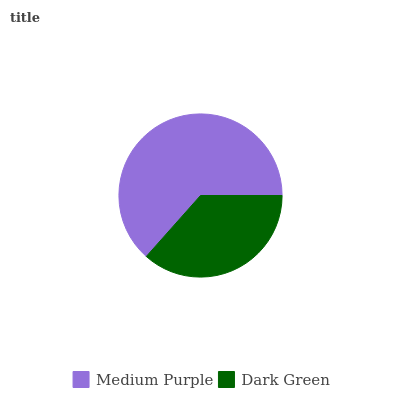Is Dark Green the minimum?
Answer yes or no. Yes. Is Medium Purple the maximum?
Answer yes or no. Yes. Is Dark Green the maximum?
Answer yes or no. No. Is Medium Purple greater than Dark Green?
Answer yes or no. Yes. Is Dark Green less than Medium Purple?
Answer yes or no. Yes. Is Dark Green greater than Medium Purple?
Answer yes or no. No. Is Medium Purple less than Dark Green?
Answer yes or no. No. Is Medium Purple the high median?
Answer yes or no. Yes. Is Dark Green the low median?
Answer yes or no. Yes. Is Dark Green the high median?
Answer yes or no. No. Is Medium Purple the low median?
Answer yes or no. No. 